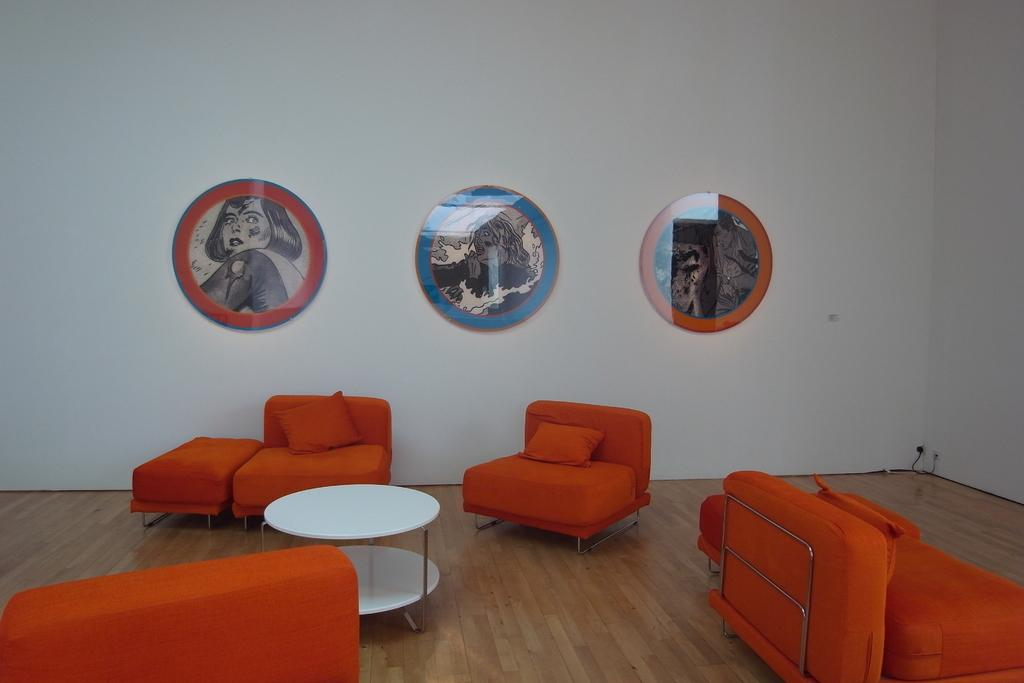What type of furniture is present in the room? There are sofa chairs in the room. What other piece of furniture can be found in the room? There is a table in the room. Are there any decorative items on the walls? Yes, there are photo frames on the wall. What is the mass of the sofa chairs in the room? The mass of the sofa chairs cannot be determined from the image alone, as it does not provide information about their weight or size. 